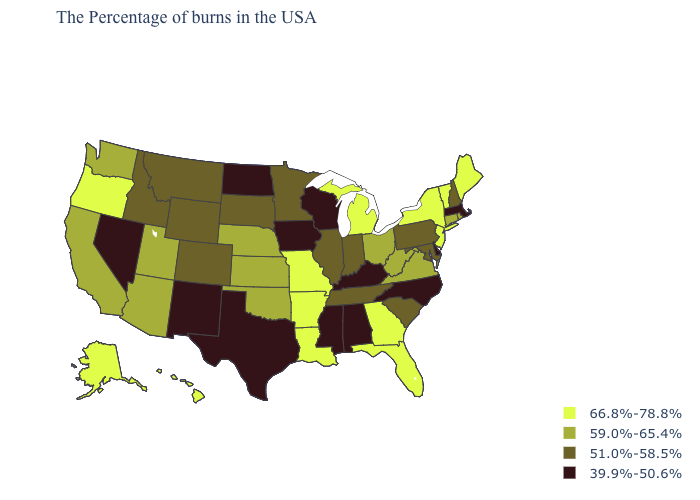Among the states that border West Virginia , which have the highest value?
Keep it brief. Virginia, Ohio. What is the value of Delaware?
Short answer required. 39.9%-50.6%. What is the value of Kentucky?
Answer briefly. 39.9%-50.6%. What is the value of Oklahoma?
Concise answer only. 59.0%-65.4%. What is the value of Florida?
Keep it brief. 66.8%-78.8%. Name the states that have a value in the range 66.8%-78.8%?
Short answer required. Maine, Vermont, New York, New Jersey, Florida, Georgia, Michigan, Louisiana, Missouri, Arkansas, Oregon, Alaska, Hawaii. What is the value of Tennessee?
Give a very brief answer. 51.0%-58.5%. Which states have the highest value in the USA?
Answer briefly. Maine, Vermont, New York, New Jersey, Florida, Georgia, Michigan, Louisiana, Missouri, Arkansas, Oregon, Alaska, Hawaii. What is the lowest value in the USA?
Short answer required. 39.9%-50.6%. What is the value of Montana?
Keep it brief. 51.0%-58.5%. What is the value of Texas?
Concise answer only. 39.9%-50.6%. Does New Jersey have the highest value in the Northeast?
Be succinct. Yes. What is the lowest value in the South?
Give a very brief answer. 39.9%-50.6%. What is the value of Maine?
Concise answer only. 66.8%-78.8%. Does Delaware have a lower value than Tennessee?
Keep it brief. Yes. 